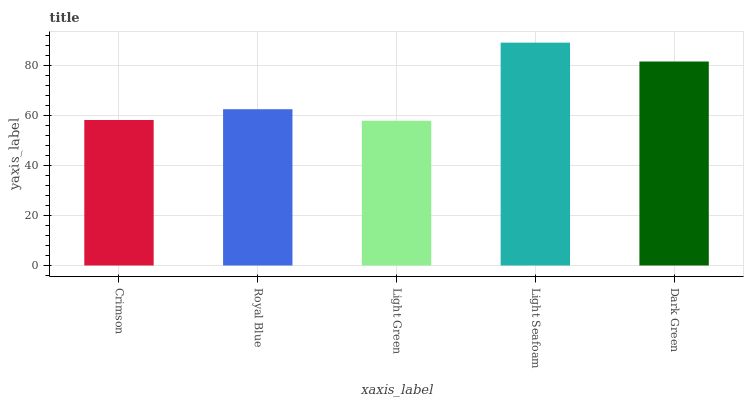Is Royal Blue the minimum?
Answer yes or no. No. Is Royal Blue the maximum?
Answer yes or no. No. Is Royal Blue greater than Crimson?
Answer yes or no. Yes. Is Crimson less than Royal Blue?
Answer yes or no. Yes. Is Crimson greater than Royal Blue?
Answer yes or no. No. Is Royal Blue less than Crimson?
Answer yes or no. No. Is Royal Blue the high median?
Answer yes or no. Yes. Is Royal Blue the low median?
Answer yes or no. Yes. Is Light Seafoam the high median?
Answer yes or no. No. Is Crimson the low median?
Answer yes or no. No. 